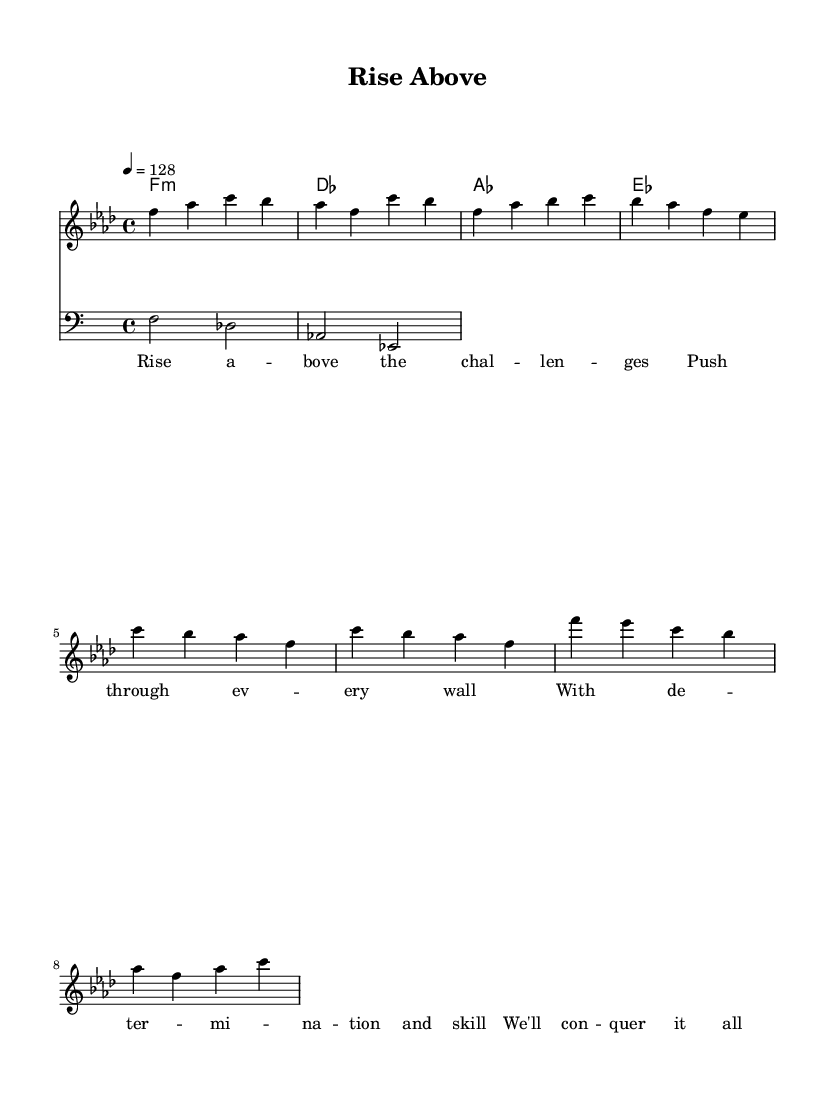What is the key signature of this music? The key signature is F minor, which consists of four flats (B♭, E♭, A♭, and D♭). This can be identified from the key signature shown at the beginning of the staff in the score.
Answer: F minor What is the time signature of this music? The time signature is 4/4, which indicates that there are four beats per measure and the quarter note receives one beat. This can be seen at the beginning of the score next to the key signature.
Answer: 4/4 What is the tempo marking for this piece? The tempo marking is 128 beats per minute, indicated by the number '128' beneath the tempo marking symbol. This suggests a moderate to fast pacing consistent with high-tempo house tracks.
Answer: 128 How many measures are in the melody section? The melody section consists of eight measures, which can be counted visually in the musical notation for the melody part. The grouping of notes in the staff helps in identifying the end of each measure.
Answer: Eight What chord is played with the first measure? The first measure features an F minor chord, which aligns with the harmony shown in the chord progression at the beginning of the score.
Answer: F minor Which musical elements contribute to the motivational nature of this track? The driving bassline and uplifting lyrics about overcoming challenges contribute to the motivational feel. The consistent rhythmic patterns also encourage energy and determination.
Answer: Driving bassline and uplifting lyrics What is the primary theme of the lyrics? The primary theme of the lyrics revolves around overcoming challenges and achieving goals, as indicated by phrases like "Rise above" and "We'll conquer it all." This can be inferred from the examination of the lyrical content provided.
Answer: Overcoming challenges 